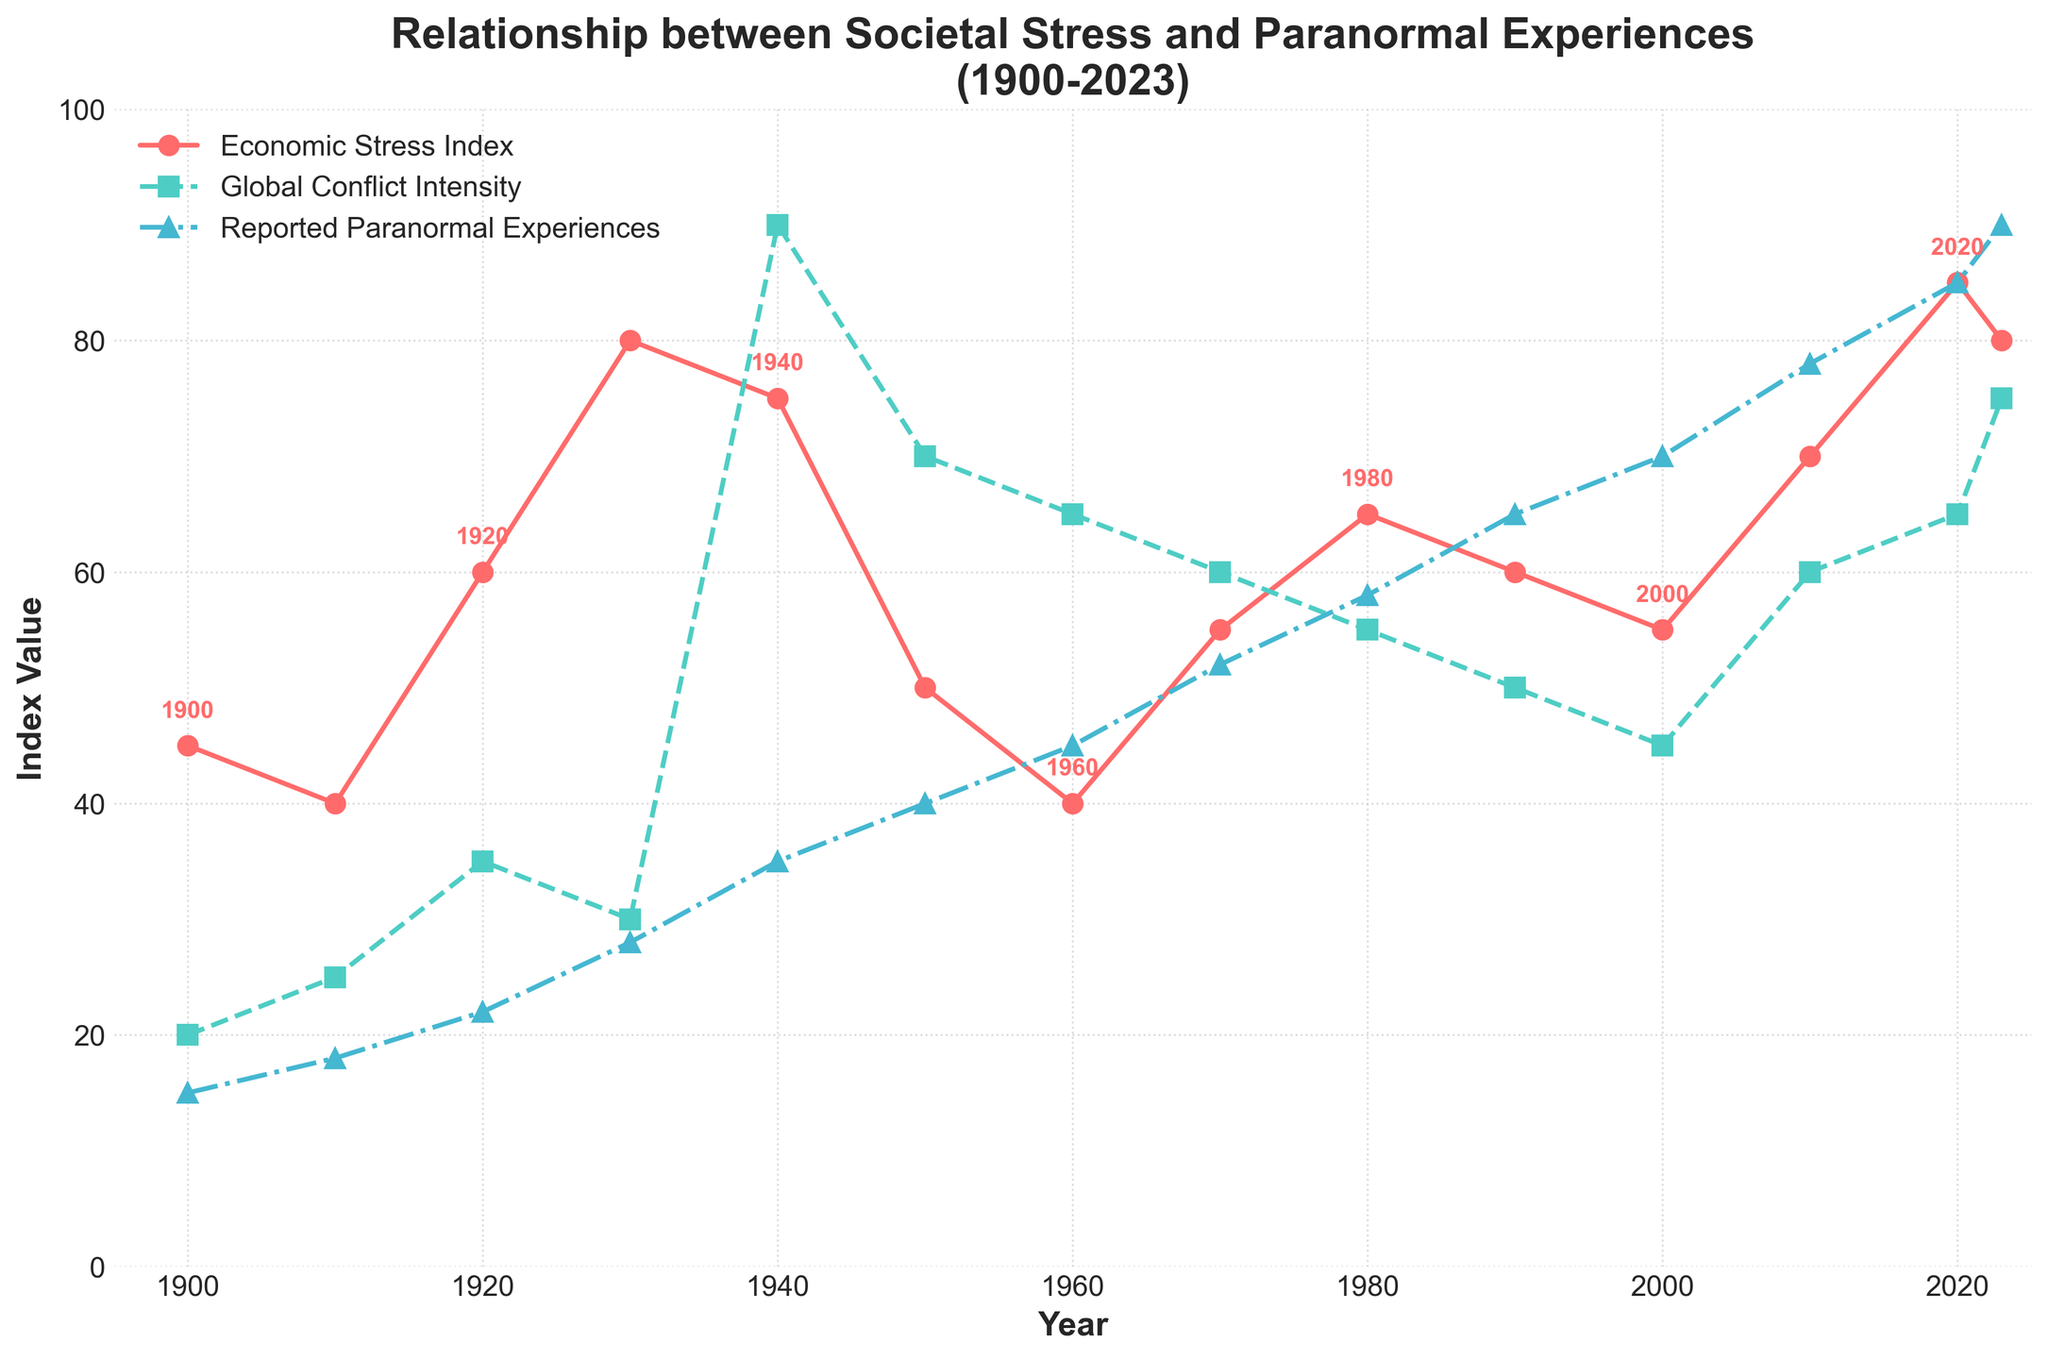What year had the highest reported paranormal experiences? In the figure, look for the highest point on the "Reported Paranormal Experiences" line. The highest value is 90, which occurs in 2023.
Answer: 2023 How did the Economic Stress Index change from 1910 to 1920? Find the values for the Economic Stress Index in 1910 and 1920. In 1910, it is 40, and in 1920, it is 60. Calculate the difference as 60 - 40 = 20.
Answer: Increased by 20 Compare the Global Conflict Intensity and Reported Paranormal Experiences in 1940. Which is higher? Find the values for both Global Conflict Intensity and Reported Paranormal Experiences in 1940. Global Conflict Intensity is 90, and Reported Paranormal Experiences is 35. Since 90 is greater than 35, Global Conflict Intensity is higher.
Answer: Global Conflict Intensity Which years have exactly equal values for Economic Stress Index and Reported Paranormal Experiences? Observe the points where the "Economic Stress Index" and "Reported Paranormal Experiences" lines intersect. In 2023, both have a value of 80.
Answer: 2023 What's the average value of the Economic Stress Index for the years 1900 to 1950? Identify the Economic Stress Index values for the years 1900, 1910, 1920, 1930, 1940, and 1950: 45, 40, 60, 80, 75, 50. Sum these values (45+40+60+80+75+50=350), then divide by the number of observations (6). 350/6 = 58.33
Answer: 58.33 Compare the slope of the "Global Conflict Intensity" line between 1930-1940 and 1950-1960. Which period had a sharper increase? Calculate the slope (change in value/change in time) for both periods. For 1930-1940: (90-30)/10 = 6, For 1950-1960: (65-70)/10 = -0.5, thus 1930-1940 has a sharper increase.
Answer: 1930-1940 What is the difference between Economic Stress Index and Global Conflict Intensity in 1980? Identify the values for both variables in 1980. The Economic Stress Index is 65 and the Global Conflict Intensity is 55. Compute the difference: 65 - 55 = 10.
Answer: 10 What can you infer about the relationship between Economic Stress Index and Reported Paranormal Experiences from 2010 to 2020? Examine these years: Economic Stress Index increased from 70 to 85 and Reported Paranormal Experiences increased from 78 to 85. Both metrics rise over these years, indicating a positive correlation.
Answer: Both increased How did reported paranormal experiences change between 1940 and 1950? Observe the values in 1940 (35) and 1950 (40). Calculate the difference: 40 - 35 = 5.
Answer: Increased by 5 